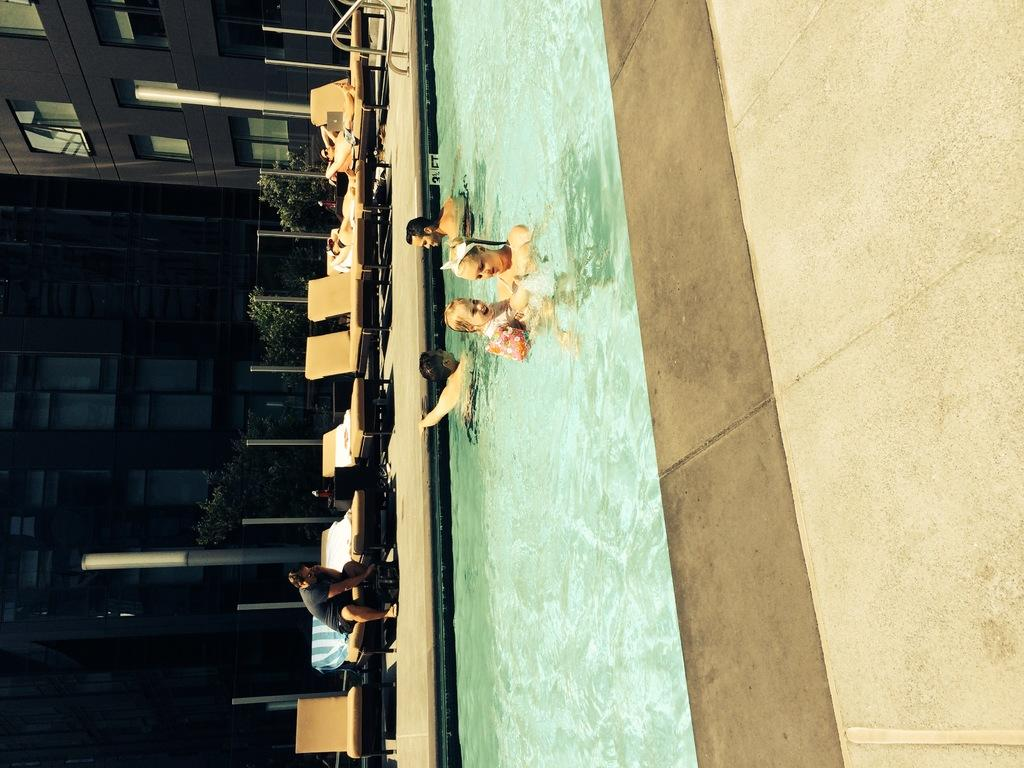What are the people in the image doing? The people in the image are in a swimming pool. What objects can be seen in the image besides the people? There are rods, chairs, poles, and a fence visible in the image. What can be seen in the background of the image? There are buildings and trees in the background of the image. What type of collar is being worn by the trees in the image? There are no collars present on the trees in the image; they are simply trees in the background. 